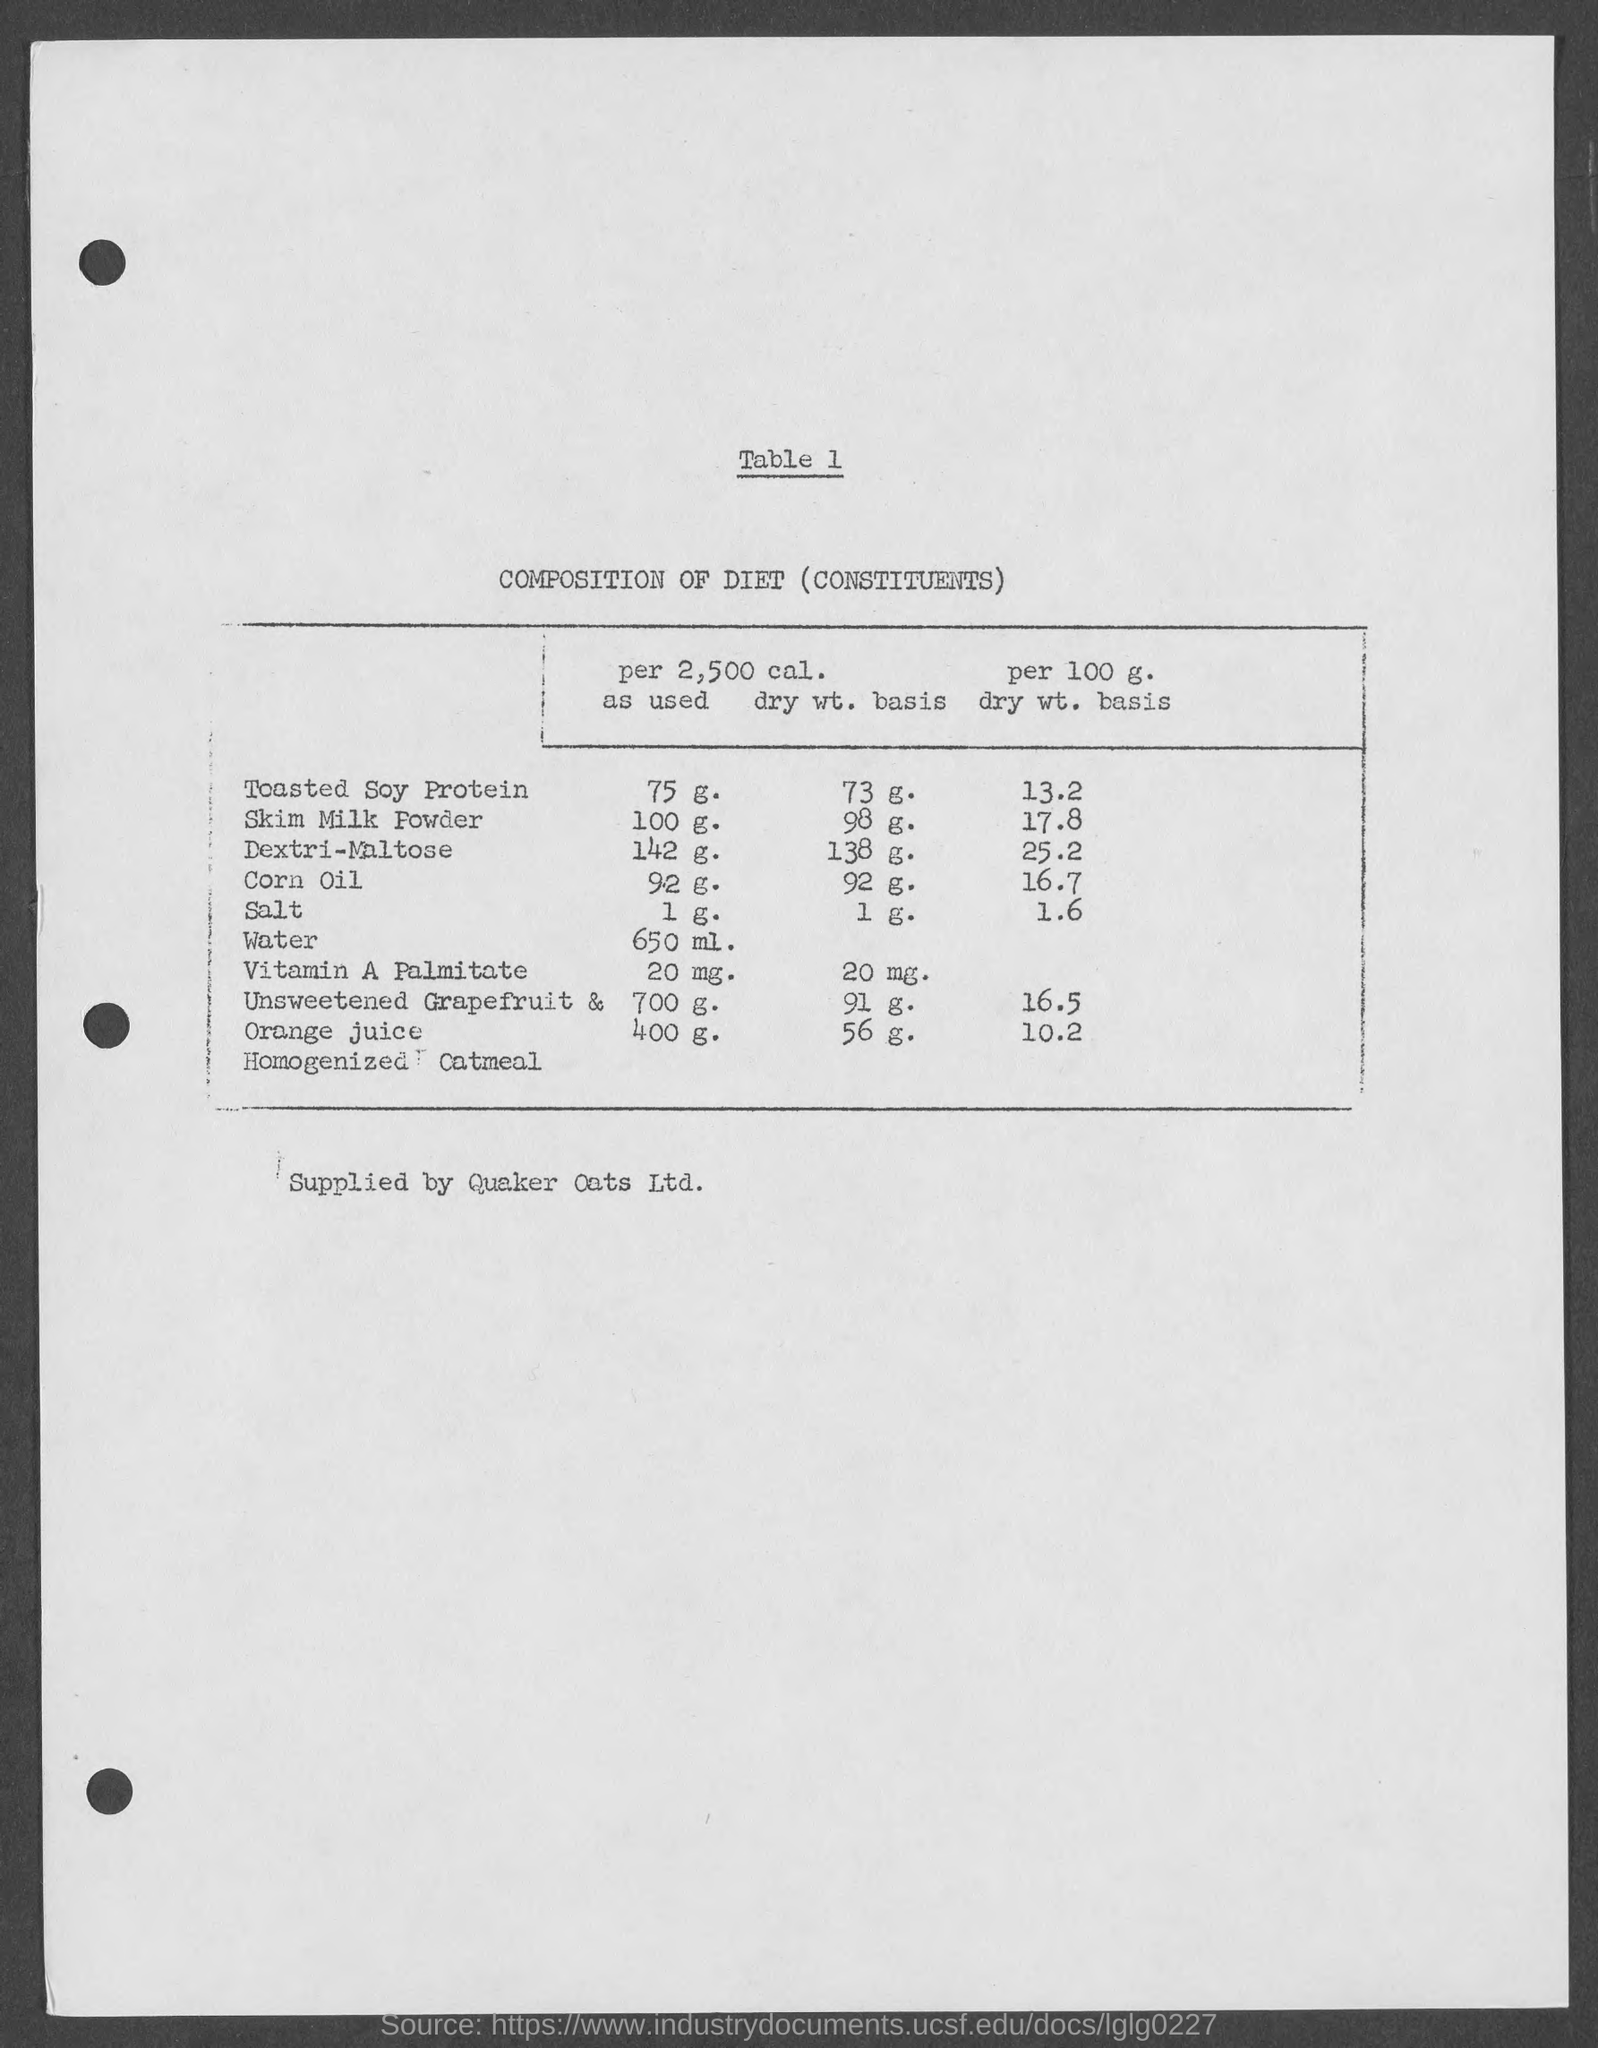What is the table number?
Provide a succinct answer. 1. What is the table heading?
Your answer should be compact. COMPOSITION OF DIET (CONSTITUENTS). 